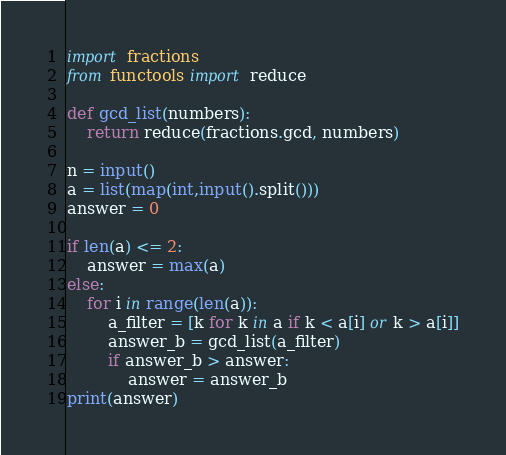Convert code to text. <code><loc_0><loc_0><loc_500><loc_500><_Python_>import fractions
from functools import reduce

def gcd_list(numbers):
    return reduce(fractions.gcd, numbers)

n = input()
a = list(map(int,input().split()))
answer = 0

if len(a) <= 2:
    answer = max(a)
else:
    for i in range(len(a)):
        a_filter = [k for k in a if k < a[i] or k > a[i]]
        answer_b = gcd_list(a_filter)
        if answer_b > answer:
            answer = answer_b
print(answer)</code> 